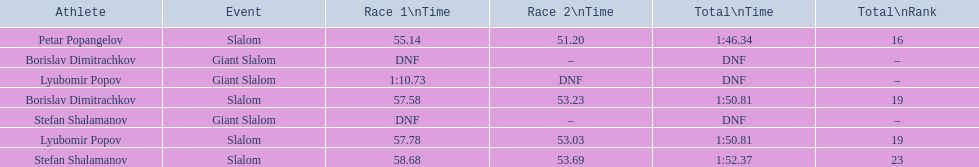Which event is the giant slalom? Giant Slalom, Giant Slalom, Giant Slalom. Which one is lyubomir popov? Lyubomir Popov. What is race 1 tim? 1:10.73. 